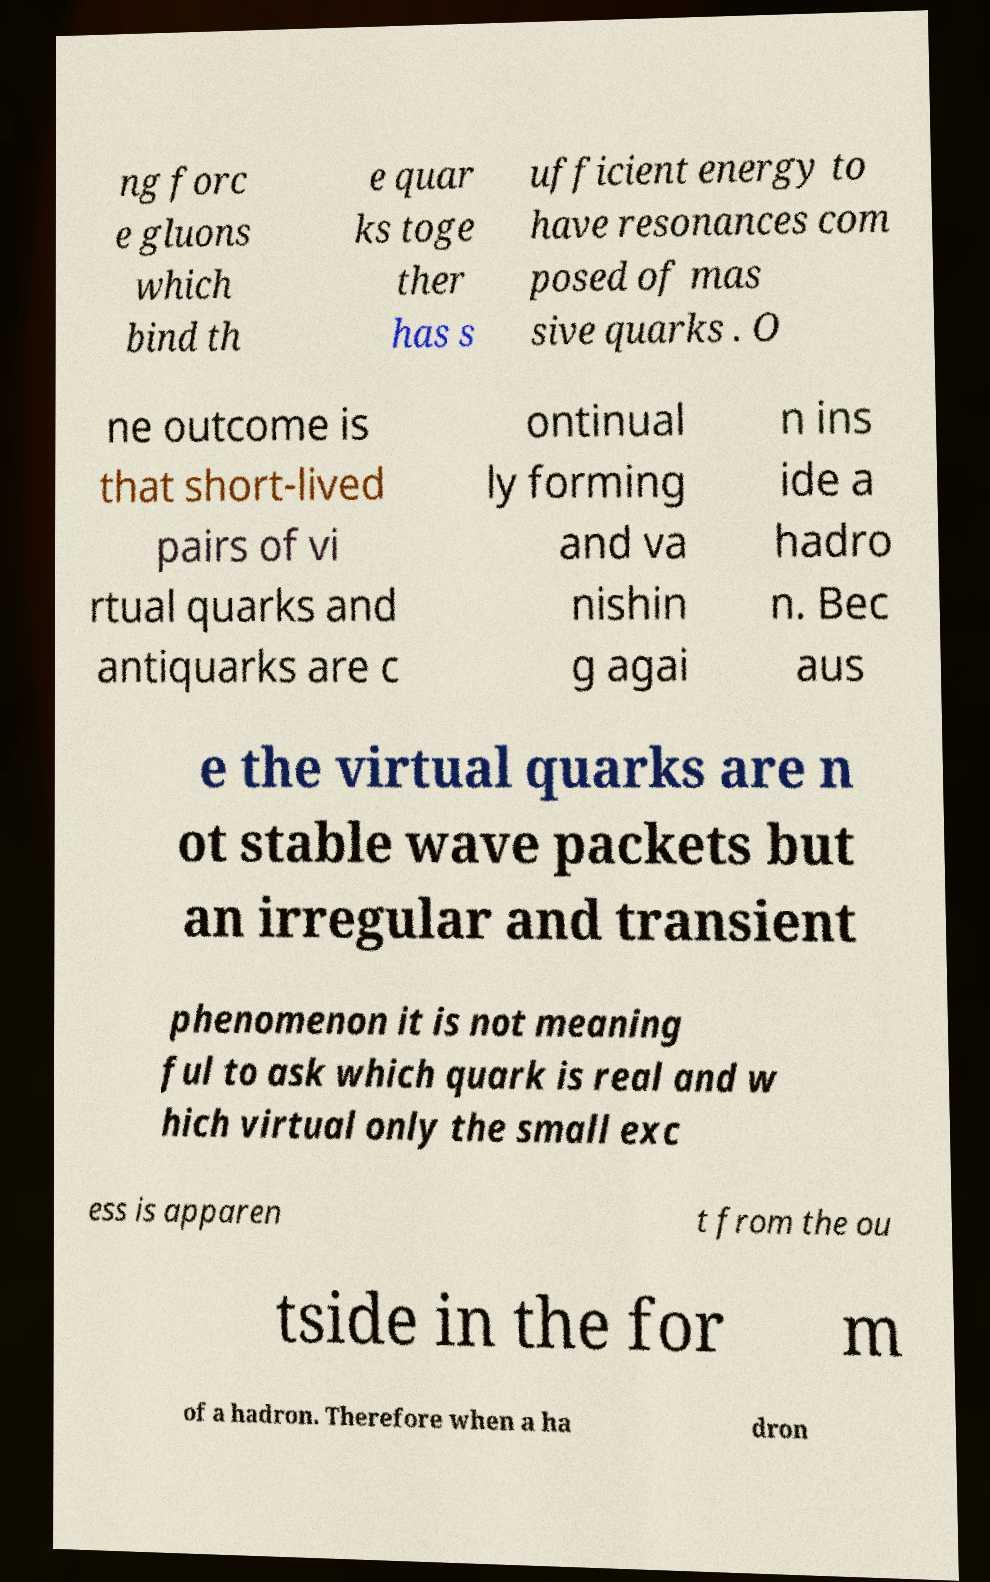Please identify and transcribe the text found in this image. ng forc e gluons which bind th e quar ks toge ther has s ufficient energy to have resonances com posed of mas sive quarks . O ne outcome is that short-lived pairs of vi rtual quarks and antiquarks are c ontinual ly forming and va nishin g agai n ins ide a hadro n. Bec aus e the virtual quarks are n ot stable wave packets but an irregular and transient phenomenon it is not meaning ful to ask which quark is real and w hich virtual only the small exc ess is apparen t from the ou tside in the for m of a hadron. Therefore when a ha dron 